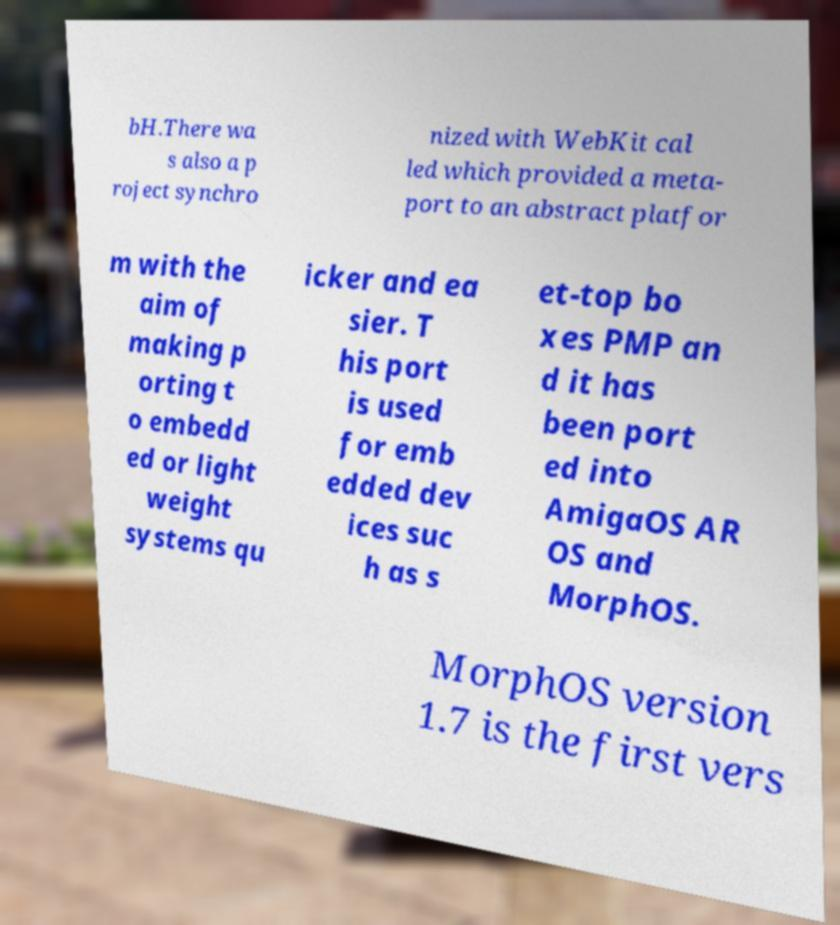Could you extract and type out the text from this image? bH.There wa s also a p roject synchro nized with WebKit cal led which provided a meta- port to an abstract platfor m with the aim of making p orting t o embedd ed or light weight systems qu icker and ea sier. T his port is used for emb edded dev ices suc h as s et-top bo xes PMP an d it has been port ed into AmigaOS AR OS and MorphOS. MorphOS version 1.7 is the first vers 